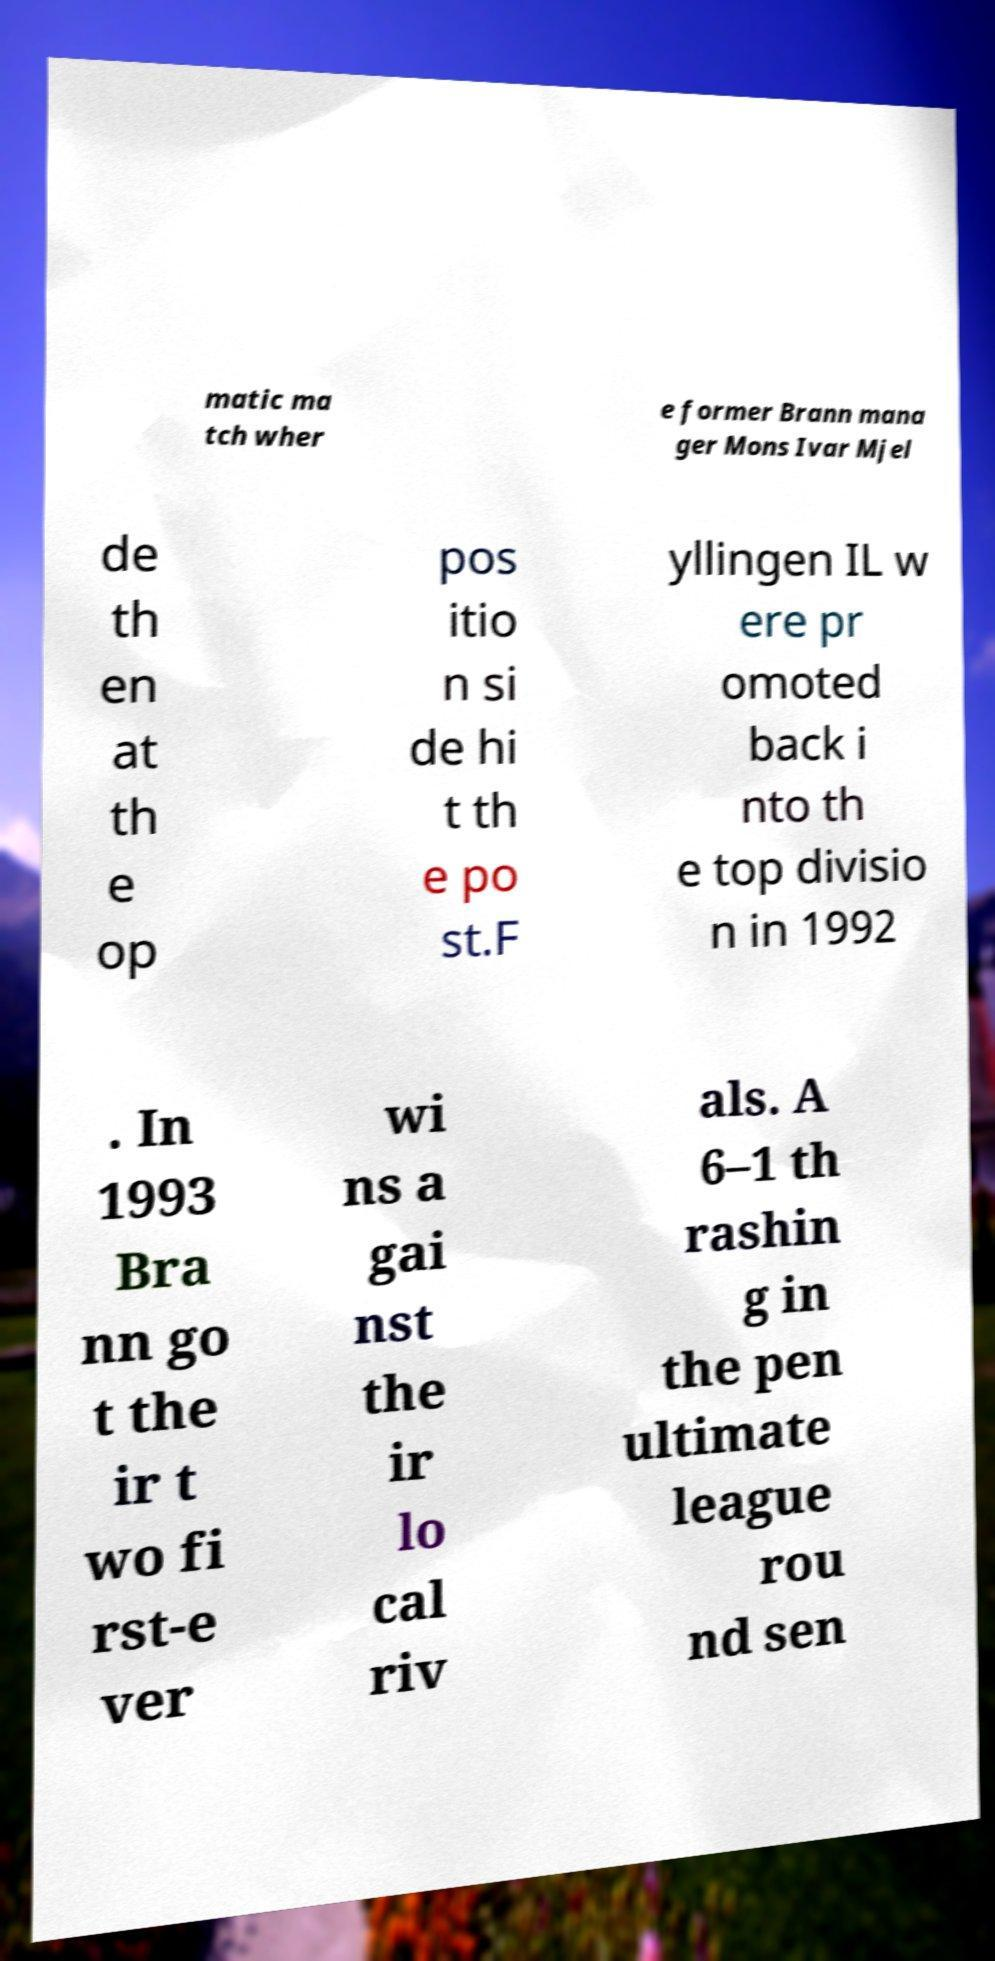I need the written content from this picture converted into text. Can you do that? matic ma tch wher e former Brann mana ger Mons Ivar Mjel de th en at th e op pos itio n si de hi t th e po st.F yllingen IL w ere pr omoted back i nto th e top divisio n in 1992 . In 1993 Bra nn go t the ir t wo fi rst-e ver wi ns a gai nst the ir lo cal riv als. A 6–1 th rashin g in the pen ultimate league rou nd sen 